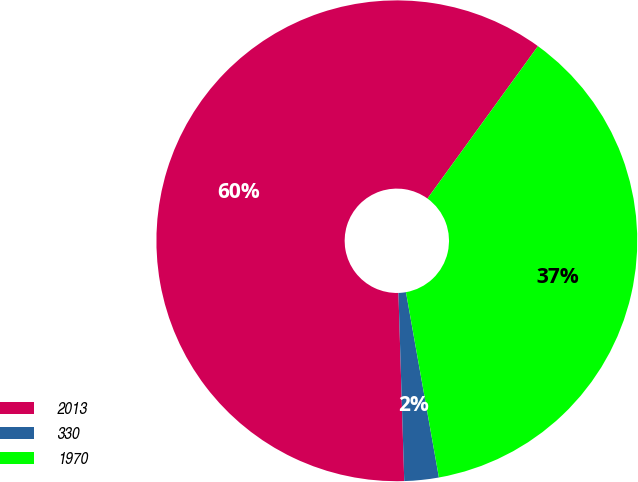<chart> <loc_0><loc_0><loc_500><loc_500><pie_chart><fcel>2013<fcel>330<fcel>1970<nl><fcel>60.47%<fcel>2.31%<fcel>37.21%<nl></chart> 